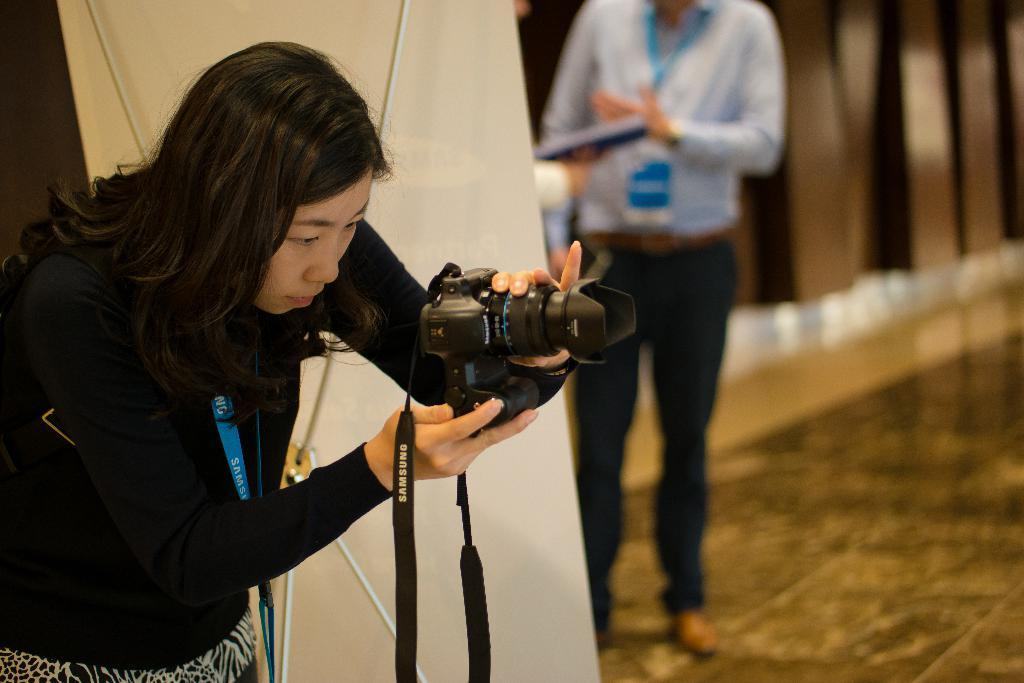Who is the main subject in the image? There is a lady in the image. What is the lady wearing? The lady is wearing a black dress. What is the lady holding in the image? The lady is holding a camera. What is the lady doing with the camera? The lady is capturing a picture. What can be seen in the background of the image? There is a stand, a banner, and a person standing in the background of the image. How many matches are being played in the image? There is no reference to any matches or sports events in the image; it features a lady capturing a picture. How many girls are present in the image? The image only features one lady, not multiple girls. 